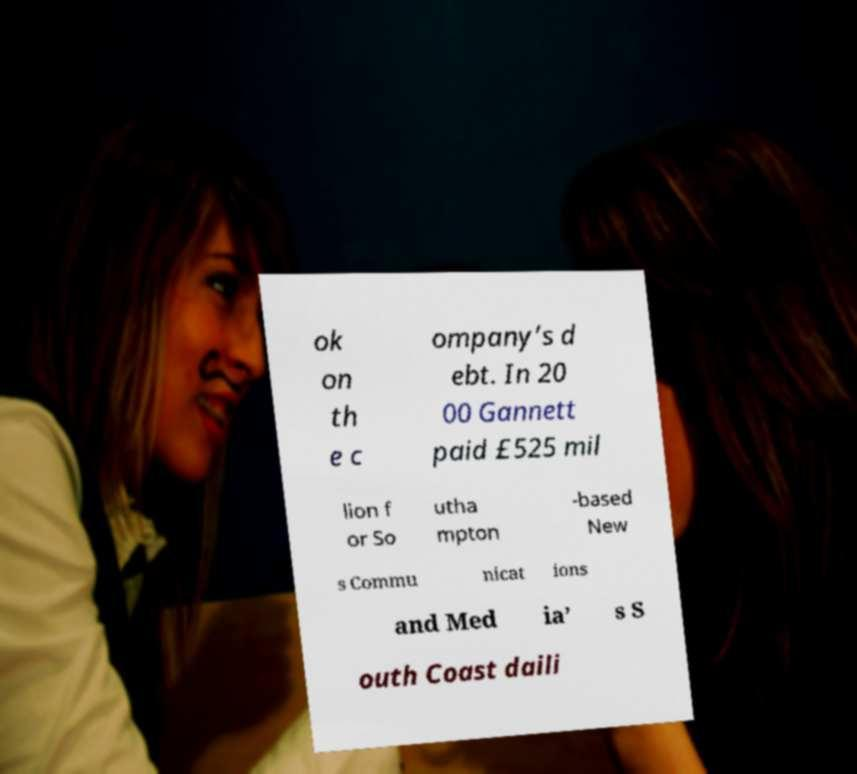I need the written content from this picture converted into text. Can you do that? ok on th e c ompany’s d ebt. In 20 00 Gannett paid £525 mil lion f or So utha mpton -based New s Commu nicat ions and Med ia’ s S outh Coast daili 